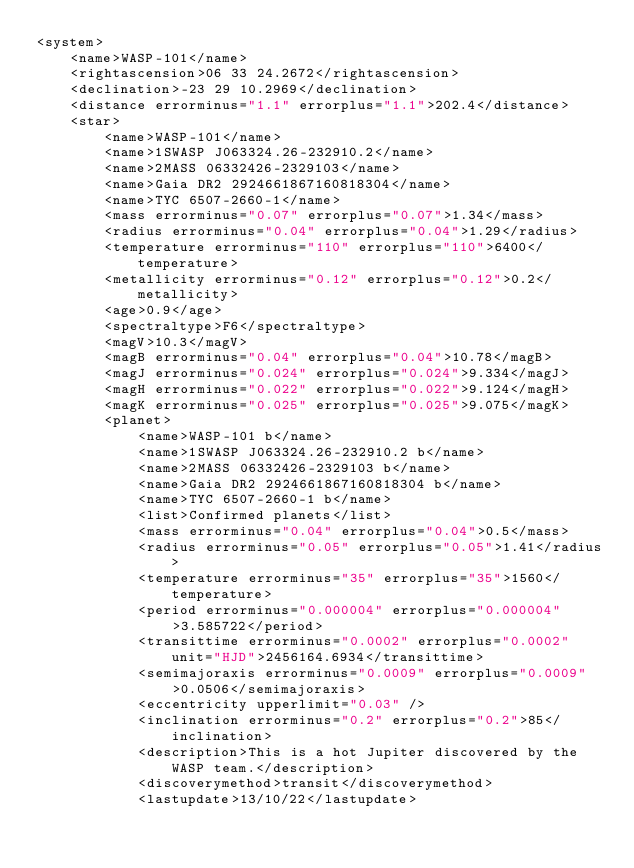Convert code to text. <code><loc_0><loc_0><loc_500><loc_500><_XML_><system>
	<name>WASP-101</name>
	<rightascension>06 33 24.2672</rightascension>
	<declination>-23 29 10.2969</declination>
	<distance errorminus="1.1" errorplus="1.1">202.4</distance>
	<star>
		<name>WASP-101</name>
		<name>1SWASP J063324.26-232910.2</name>
		<name>2MASS 06332426-2329103</name>
		<name>Gaia DR2 2924661867160818304</name>
		<name>TYC 6507-2660-1</name>
		<mass errorminus="0.07" errorplus="0.07">1.34</mass>
		<radius errorminus="0.04" errorplus="0.04">1.29</radius>
		<temperature errorminus="110" errorplus="110">6400</temperature>
		<metallicity errorminus="0.12" errorplus="0.12">0.2</metallicity>
		<age>0.9</age>
		<spectraltype>F6</spectraltype>
		<magV>10.3</magV>
		<magB errorminus="0.04" errorplus="0.04">10.78</magB>
		<magJ errorminus="0.024" errorplus="0.024">9.334</magJ>
		<magH errorminus="0.022" errorplus="0.022">9.124</magH>
		<magK errorminus="0.025" errorplus="0.025">9.075</magK>
		<planet>
			<name>WASP-101 b</name>
			<name>1SWASP J063324.26-232910.2 b</name>
			<name>2MASS 06332426-2329103 b</name>
			<name>Gaia DR2 2924661867160818304 b</name>
			<name>TYC 6507-2660-1 b</name>
			<list>Confirmed planets</list>
			<mass errorminus="0.04" errorplus="0.04">0.5</mass>
			<radius errorminus="0.05" errorplus="0.05">1.41</radius>
			<temperature errorminus="35" errorplus="35">1560</temperature>
			<period errorminus="0.000004" errorplus="0.000004">3.585722</period>
			<transittime errorminus="0.0002" errorplus="0.0002" unit="HJD">2456164.6934</transittime>
			<semimajoraxis errorminus="0.0009" errorplus="0.0009">0.0506</semimajoraxis>
			<eccentricity upperlimit="0.03" />
			<inclination errorminus="0.2" errorplus="0.2">85</inclination>
			<description>This is a hot Jupiter discovered by the WASP team.</description>
			<discoverymethod>transit</discoverymethod>
			<lastupdate>13/10/22</lastupdate></code> 